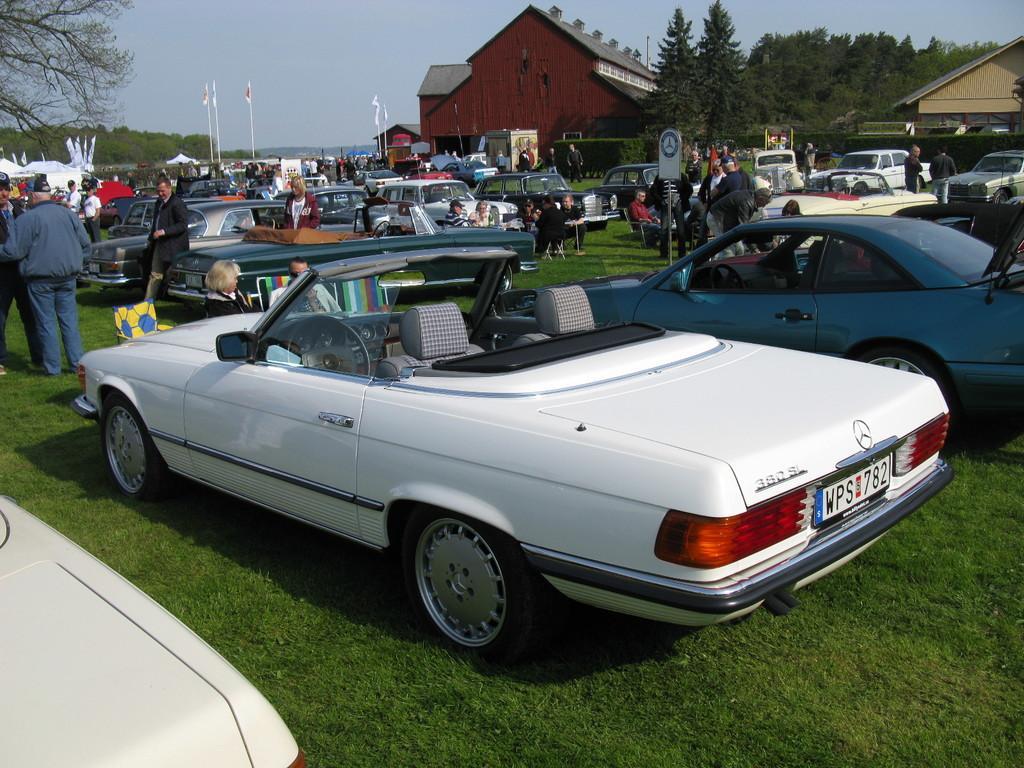Please provide a concise description of this image. In this picture we can see some cars, at the bottom there is grass, in the background there are some people standing and some people are sitting, we can also see trees, flags, houses in the background, there is a board in the middle, we can see the sky at the top of the picture. 